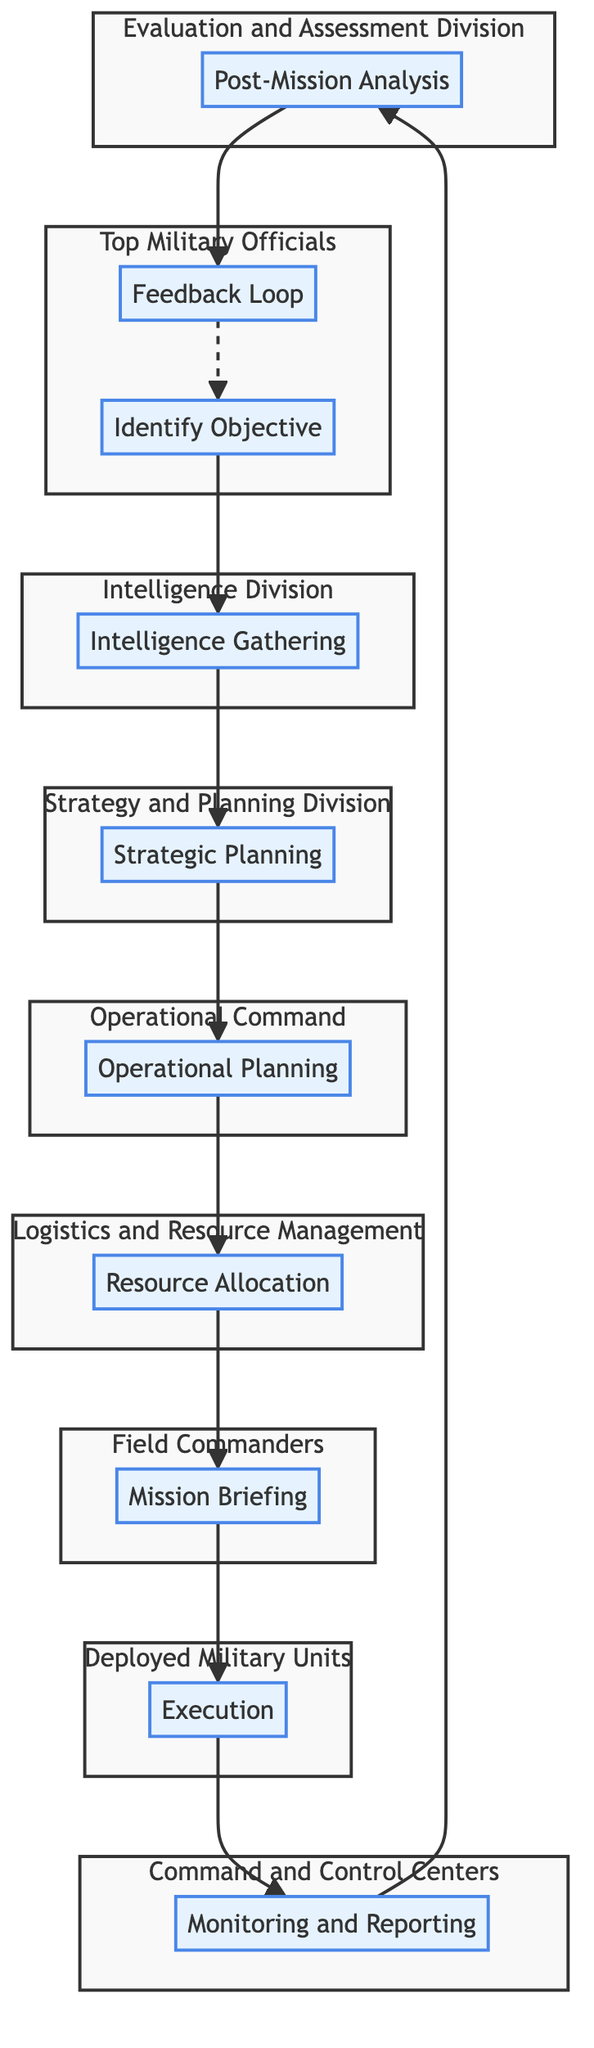What is the first step in the hierarchy? The first step in the hierarchy is the "Identify Objective," which initiates the chain of command.
Answer: Identify Objective Which entity is responsible for Strategic Planning? The entity responsible for Strategic Planning is the "Strategy and Planning Division." This is indicated clearly in the diagram.
Answer: Strategy and Planning Division How many steps are there in the decision-making process? There are a total of ten steps in the decision-making process, as represented by the nodes in the flowchart.
Answer: Ten What follows Resource Allocation in the flowchart? The step that follows Resource Allocation is "Mission Briefing," where the plan is communicated to various units.
Answer: Mission Briefing Which step is directly monitored by Command and Control Centers? The "Monitoring and Reporting" step is directly monitored by Command and Control Centers, where mission progress is continuously observed.
Answer: Monitoring and Reporting What entities are sub-divided under Top Military Officials? The entities sub-divided under Top Military Officials include "Identify Objective" and "Feedback Loop," as shown in the subgraph.
Answer: Identify Objective and Feedback Loop If the "Execution" phase encounters issues, which step should they report to? If there are issues during the Execution phase, they should report to "Monitoring and Reporting" to maintain situational awareness.
Answer: Monitoring and Reporting Which step involves assigning resources? The step that involves assigning resources is "Resource Allocation," ensuring that necessary personnel, equipment, and logistics are allocated.
Answer: Resource Allocation What type of analysis is performed after the mission? The type of analysis performed after the mission is "Post-Mission Analysis," where outcomes are assessed for successes and improvement areas.
Answer: Post-Mission Analysis 